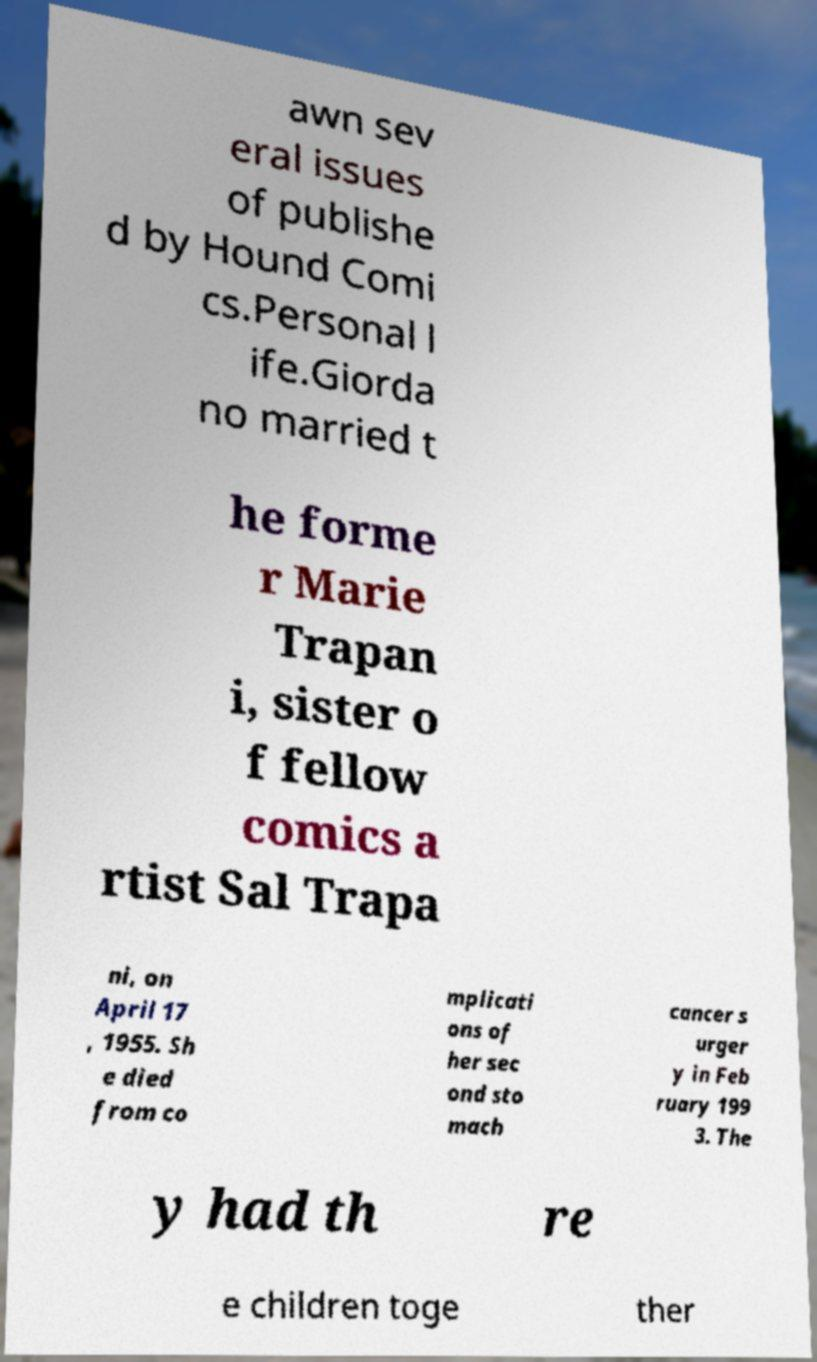Can you accurately transcribe the text from the provided image for me? awn sev eral issues of publishe d by Hound Comi cs.Personal l ife.Giorda no married t he forme r Marie Trapan i, sister o f fellow comics a rtist Sal Trapa ni, on April 17 , 1955. Sh e died from co mplicati ons of her sec ond sto mach cancer s urger y in Feb ruary 199 3. The y had th re e children toge ther 